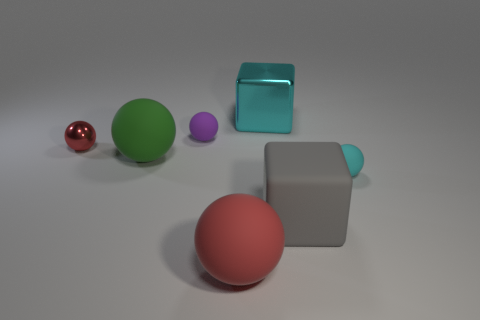Subtract all spheres. How many objects are left? 2 Subtract 1 cubes. How many cubes are left? 1 Subtract all gray blocks. Subtract all cyan cylinders. How many blocks are left? 1 Subtract all red cubes. How many gray balls are left? 0 Subtract all big rubber objects. Subtract all small purple rubber spheres. How many objects are left? 3 Add 3 big gray things. How many big gray things are left? 4 Add 7 small shiny balls. How many small shiny balls exist? 8 Add 3 purple matte objects. How many objects exist? 10 Subtract all cyan blocks. How many blocks are left? 1 Subtract all small purple spheres. How many spheres are left? 4 